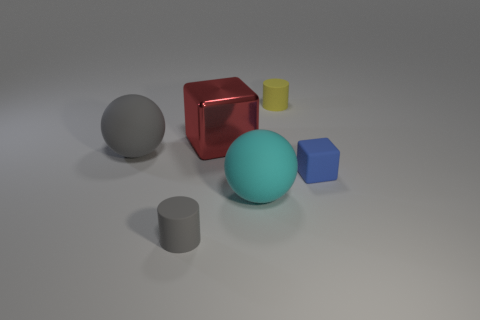How many other things are the same color as the big cube?
Your answer should be very brief. 0. The cyan rubber thing that is the same size as the red shiny object is what shape?
Keep it short and to the point. Sphere. How many gray spheres are left of the cube behind the tiny matte thing that is right of the yellow rubber cylinder?
Your answer should be very brief. 1. What number of matte objects are cyan spheres or gray balls?
Provide a succinct answer. 2. There is a tiny rubber thing that is both in front of the small yellow object and on the left side of the tiny block; what is its color?
Provide a succinct answer. Gray. There is a gray thing behind the matte block; is it the same size as the red block?
Your response must be concise. Yes. How many things are small rubber cylinders left of the yellow rubber thing or spheres?
Your answer should be very brief. 3. Are there any yellow matte blocks of the same size as the cyan thing?
Your response must be concise. No. There is a blue object that is the same size as the yellow cylinder; what is it made of?
Your response must be concise. Rubber. The small object that is both in front of the large gray rubber object and on the left side of the blue cube has what shape?
Offer a terse response. Cylinder. 